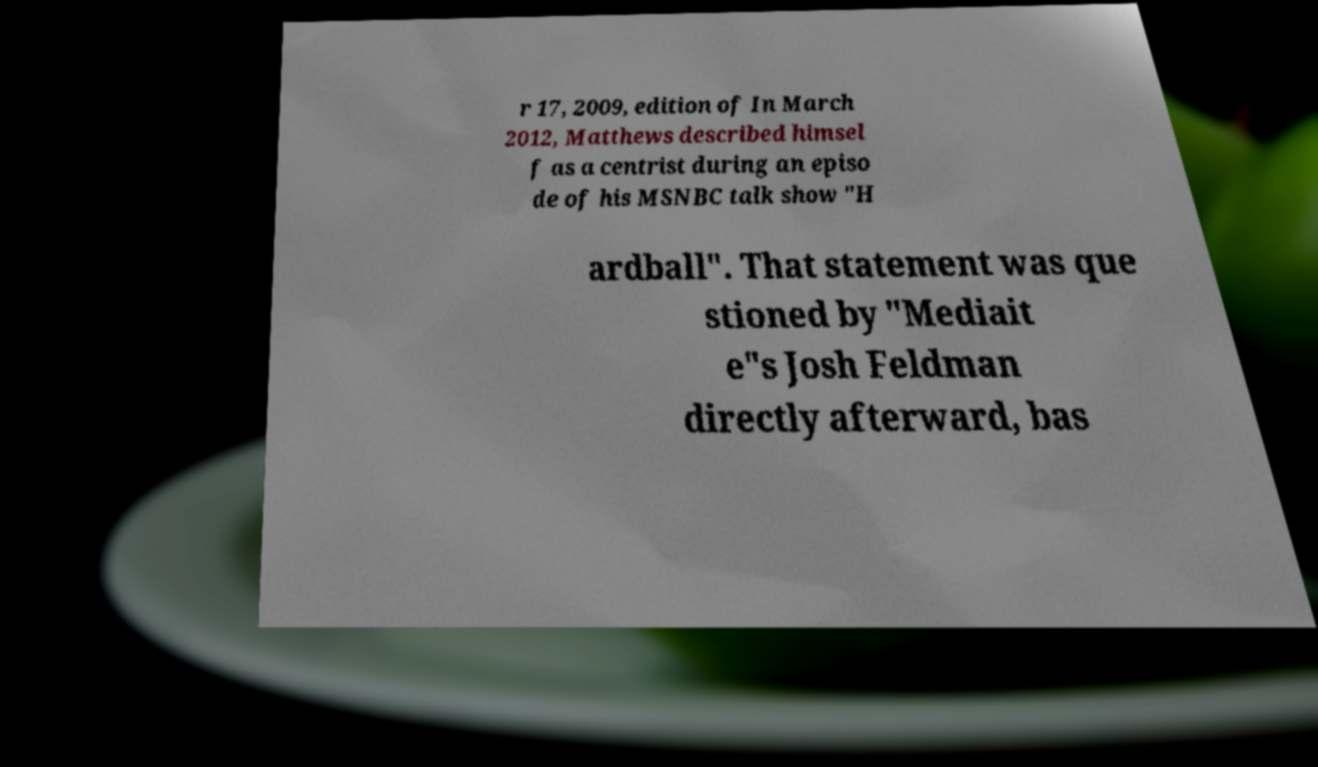What messages or text are displayed in this image? I need them in a readable, typed format. r 17, 2009, edition of In March 2012, Matthews described himsel f as a centrist during an episo de of his MSNBC talk show "H ardball". That statement was que stioned by "Mediait e"s Josh Feldman directly afterward, bas 